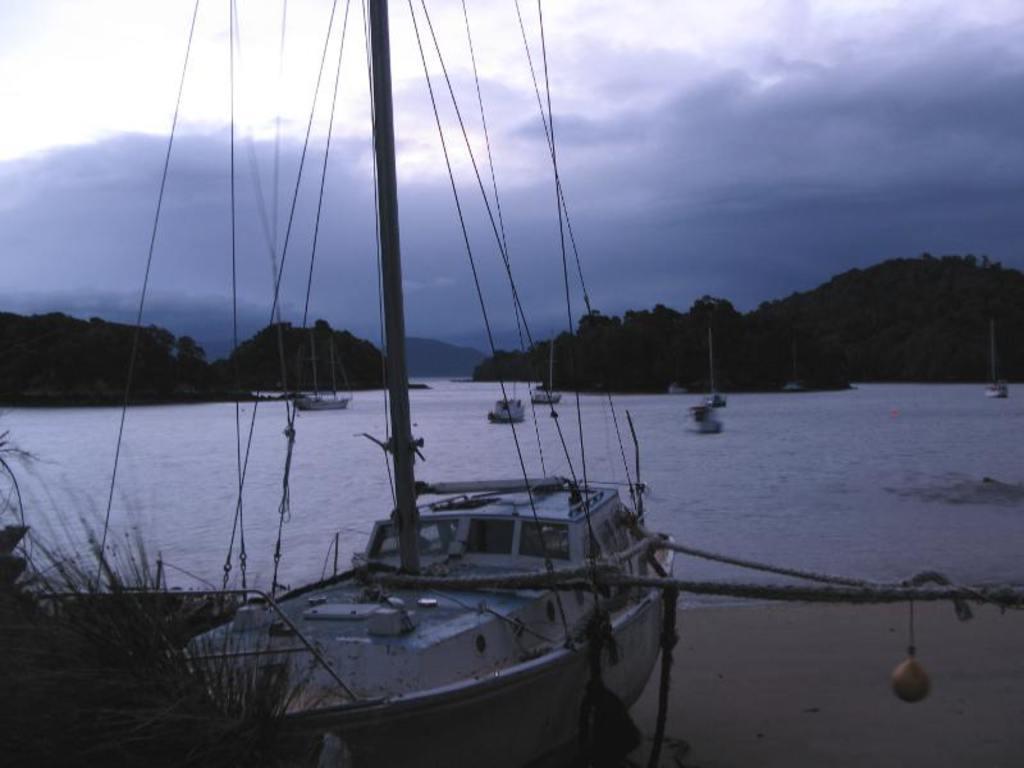Could you give a brief overview of what you see in this image? There is a boat with poles. There are ropes. On the left corner there are plants. In the back there is water. There are boats in the water. In the background there are hills and sky. 